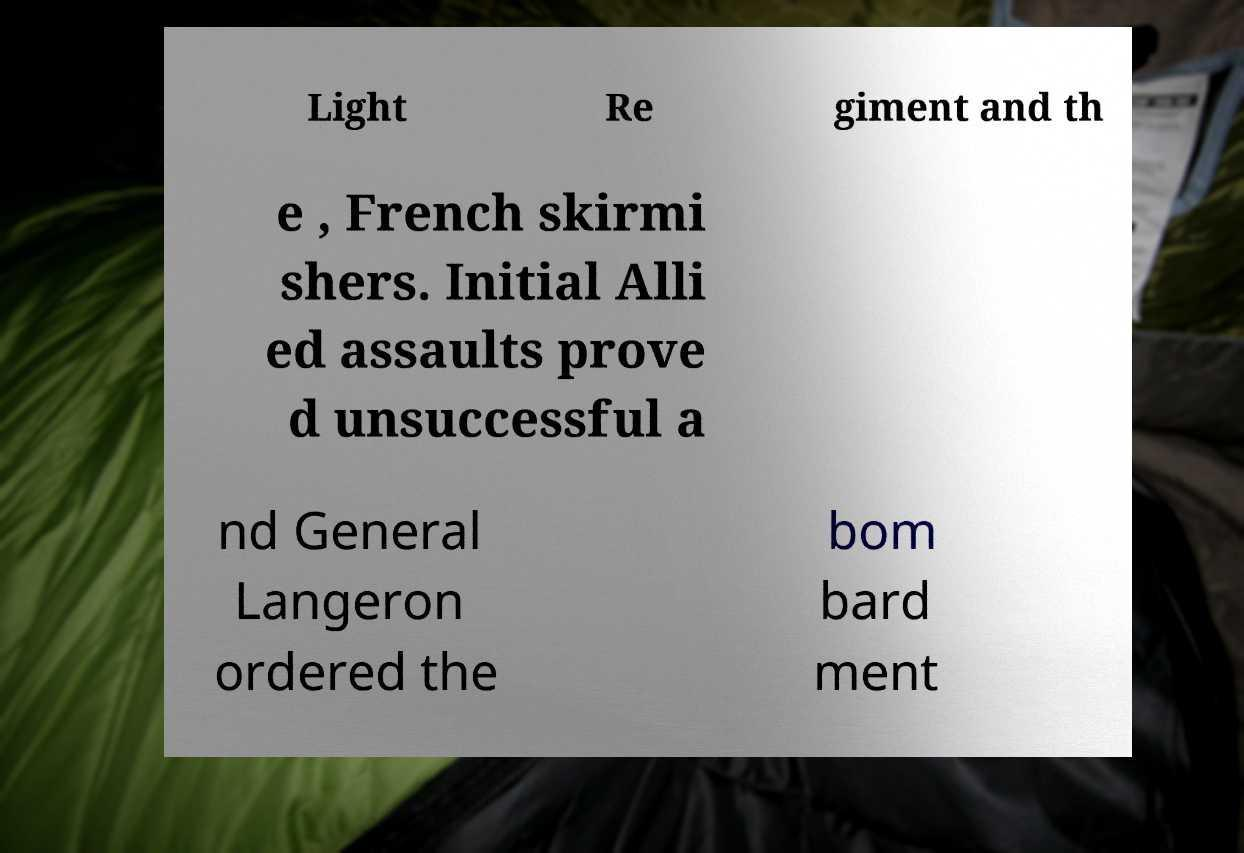There's text embedded in this image that I need extracted. Can you transcribe it verbatim? Light Re giment and th e , French skirmi shers. Initial Alli ed assaults prove d unsuccessful a nd General Langeron ordered the bom bard ment 